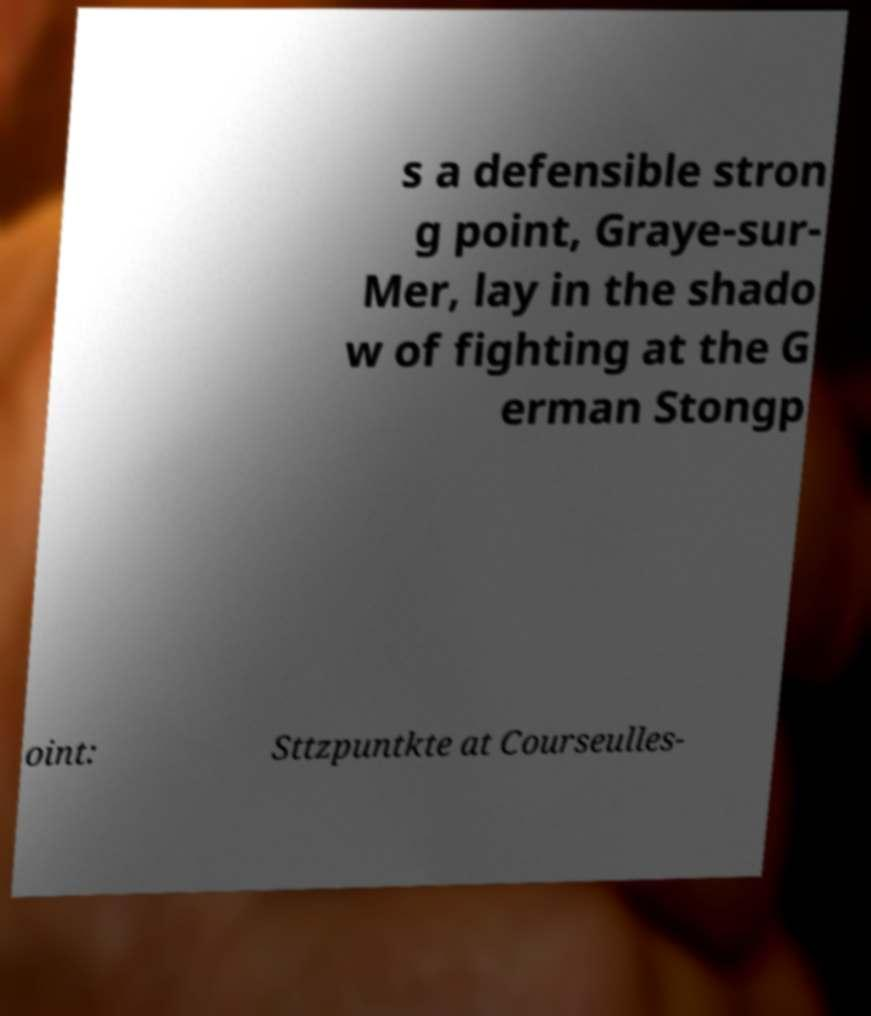There's text embedded in this image that I need extracted. Can you transcribe it verbatim? s a defensible stron g point, Graye-sur- Mer, lay in the shado w of fighting at the G erman Stongp oint: Sttzpuntkte at Courseulles- 